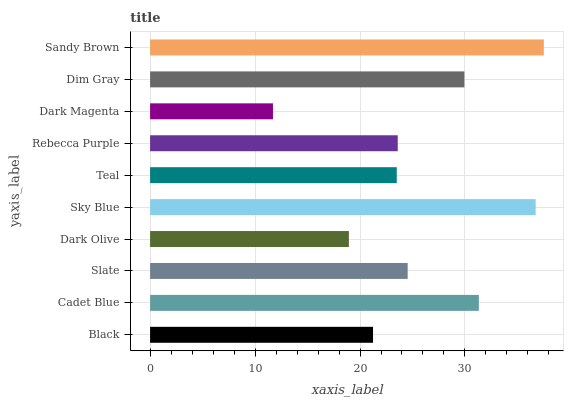Is Dark Magenta the minimum?
Answer yes or no. Yes. Is Sandy Brown the maximum?
Answer yes or no. Yes. Is Cadet Blue the minimum?
Answer yes or no. No. Is Cadet Blue the maximum?
Answer yes or no. No. Is Cadet Blue greater than Black?
Answer yes or no. Yes. Is Black less than Cadet Blue?
Answer yes or no. Yes. Is Black greater than Cadet Blue?
Answer yes or no. No. Is Cadet Blue less than Black?
Answer yes or no. No. Is Slate the high median?
Answer yes or no. Yes. Is Rebecca Purple the low median?
Answer yes or no. Yes. Is Cadet Blue the high median?
Answer yes or no. No. Is Dark Magenta the low median?
Answer yes or no. No. 